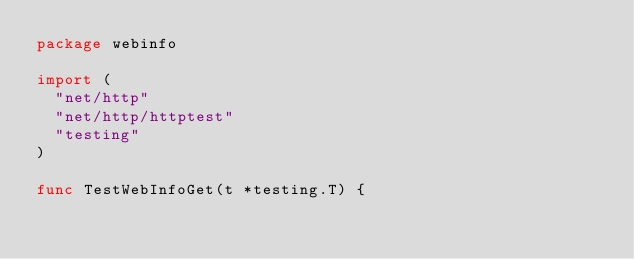Convert code to text. <code><loc_0><loc_0><loc_500><loc_500><_Go_>package webinfo

import (
	"net/http"
	"net/http/httptest"
	"testing"
)

func TestWebInfoGet(t *testing.T) {</code> 